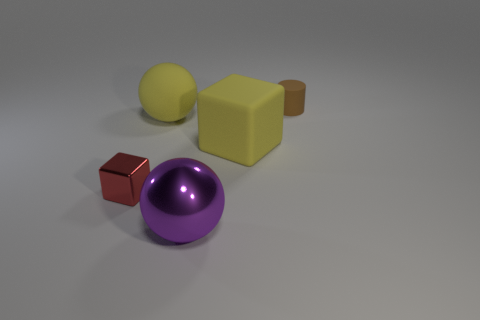Add 1 tiny gray rubber blocks. How many objects exist? 6 Subtract all cubes. How many objects are left? 3 Subtract 1 cylinders. How many cylinders are left? 0 Subtract all yellow blocks. How many yellow balls are left? 1 Subtract all cyan cubes. Subtract all blue cylinders. How many cubes are left? 2 Subtract all cylinders. Subtract all large purple balls. How many objects are left? 3 Add 4 small matte cylinders. How many small matte cylinders are left? 5 Add 3 gray spheres. How many gray spheres exist? 3 Subtract 0 red spheres. How many objects are left? 5 